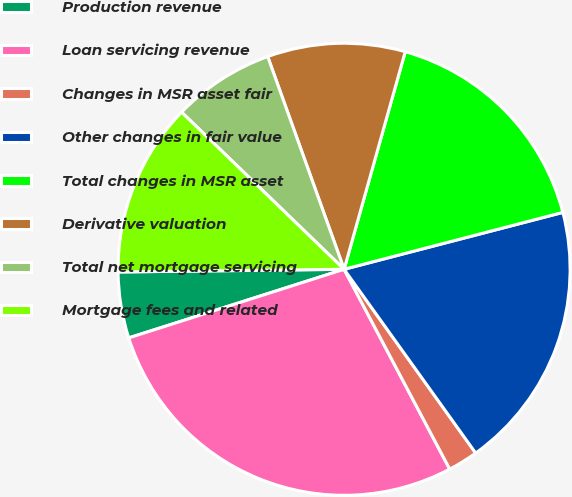<chart> <loc_0><loc_0><loc_500><loc_500><pie_chart><fcel>Production revenue<fcel>Loan servicing revenue<fcel>Changes in MSR asset fair<fcel>Other changes in fair value<fcel>Total changes in MSR asset<fcel>Derivative valuation<fcel>Total net mortgage servicing<fcel>Mortgage fees and related<nl><fcel>4.72%<fcel>27.83%<fcel>2.15%<fcel>19.16%<fcel>16.59%<fcel>9.85%<fcel>7.28%<fcel>12.42%<nl></chart> 